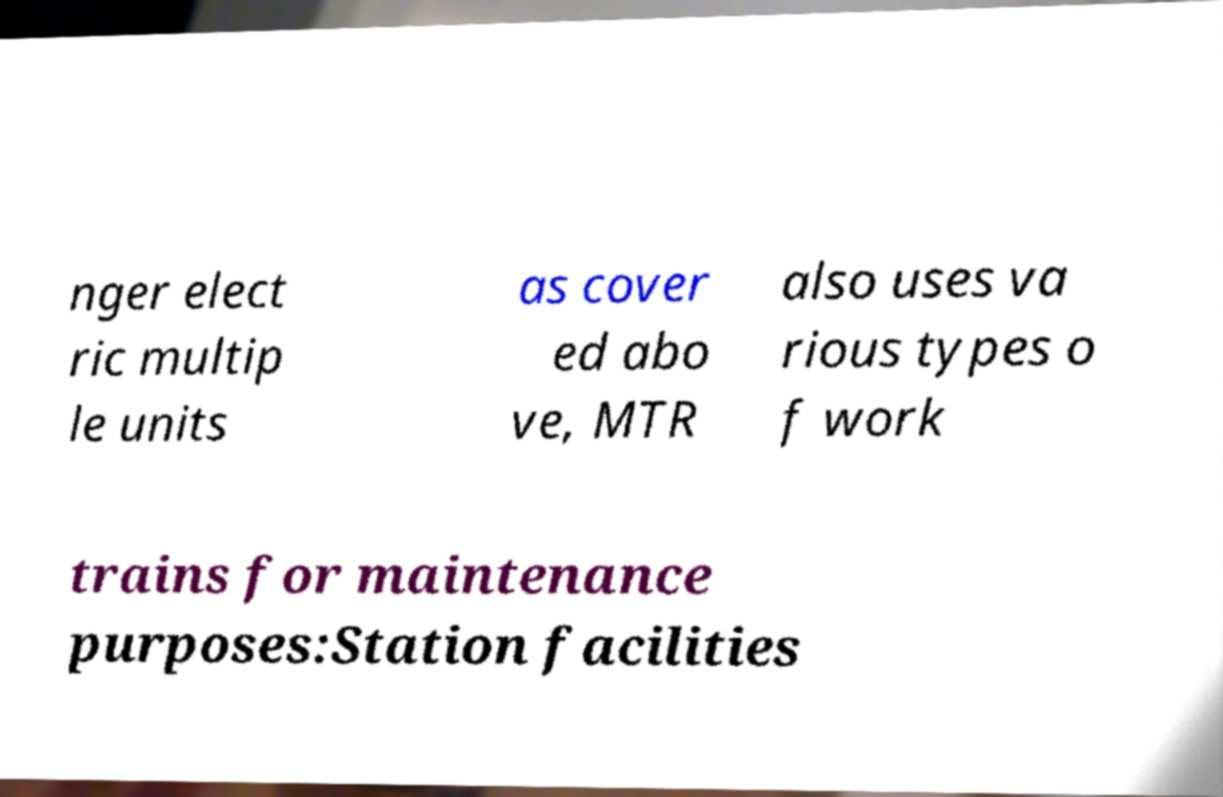Could you assist in decoding the text presented in this image and type it out clearly? nger elect ric multip le units as cover ed abo ve, MTR also uses va rious types o f work trains for maintenance purposes:Station facilities 